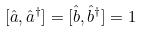Convert formula to latex. <formula><loc_0><loc_0><loc_500><loc_500>[ \hat { a } , \hat { a } ^ { \dagger } ] = [ \hat { b } , \hat { b } ^ { \dagger } ] = 1</formula> 